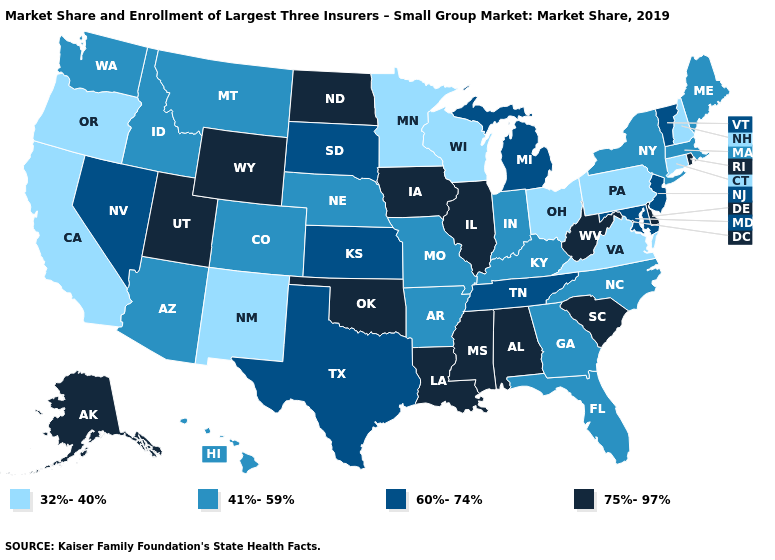What is the highest value in the West ?
Answer briefly. 75%-97%. What is the highest value in states that border New Mexico?
Short answer required. 75%-97%. Is the legend a continuous bar?
Quick response, please. No. Name the states that have a value in the range 41%-59%?
Concise answer only. Arizona, Arkansas, Colorado, Florida, Georgia, Hawaii, Idaho, Indiana, Kentucky, Maine, Massachusetts, Missouri, Montana, Nebraska, New York, North Carolina, Washington. Which states have the lowest value in the Northeast?
Short answer required. Connecticut, New Hampshire, Pennsylvania. What is the highest value in the USA?
Be succinct. 75%-97%. Which states hav the highest value in the Northeast?
Keep it brief. Rhode Island. Among the states that border Massachusetts , does Vermont have the highest value?
Answer briefly. No. Name the states that have a value in the range 60%-74%?
Short answer required. Kansas, Maryland, Michigan, Nevada, New Jersey, South Dakota, Tennessee, Texas, Vermont. Is the legend a continuous bar?
Concise answer only. No. Which states have the lowest value in the West?
Concise answer only. California, New Mexico, Oregon. Which states have the highest value in the USA?
Short answer required. Alabama, Alaska, Delaware, Illinois, Iowa, Louisiana, Mississippi, North Dakota, Oklahoma, Rhode Island, South Carolina, Utah, West Virginia, Wyoming. Name the states that have a value in the range 32%-40%?
Be succinct. California, Connecticut, Minnesota, New Hampshire, New Mexico, Ohio, Oregon, Pennsylvania, Virginia, Wisconsin. Does Massachusetts have the same value as Wyoming?
Concise answer only. No. What is the value of Rhode Island?
Give a very brief answer. 75%-97%. 